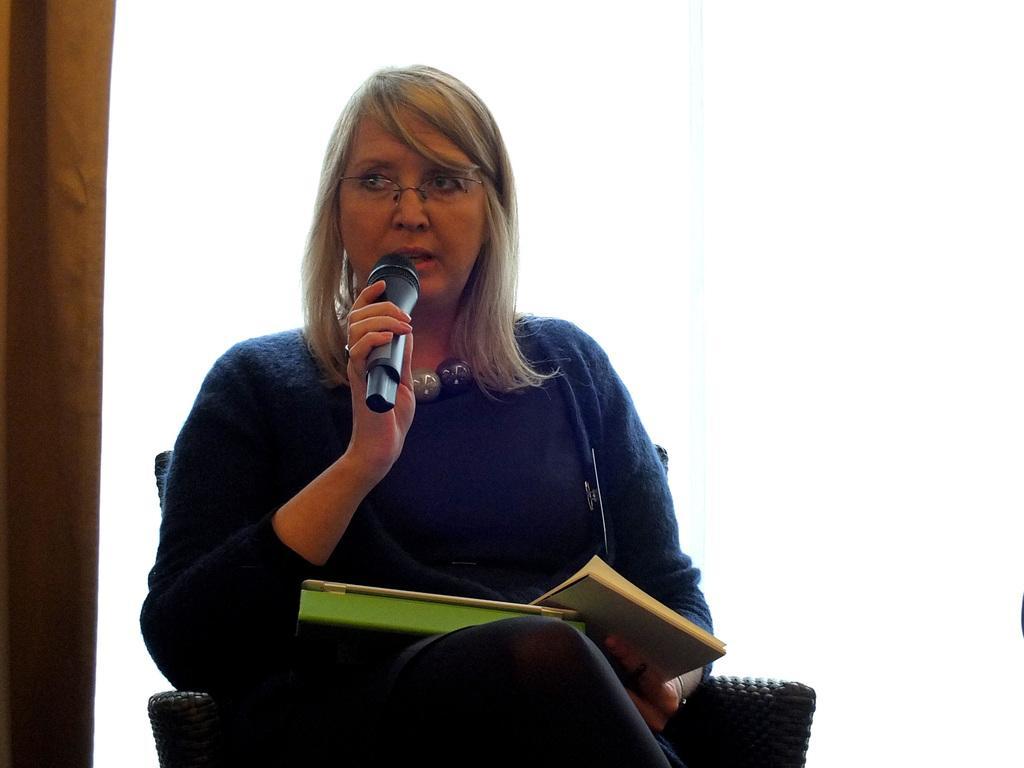Please provide a concise description of this image. In this image there is a woman who is sitting in chair and speaking with the mic. She is holding two books. 